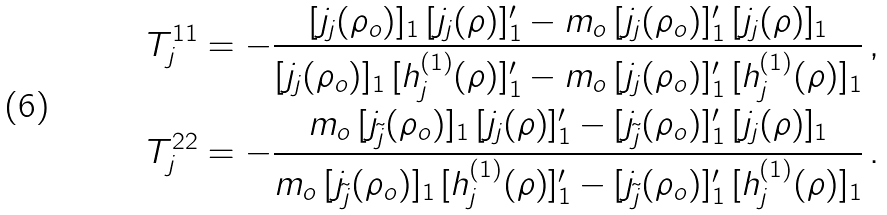<formula> <loc_0><loc_0><loc_500><loc_500>& T _ { j } ^ { 1 1 } = - \frac { [ j _ { j } ( \rho _ { o } ) ] _ { 1 } \, [ j _ { j } ( \rho ) ] ^ { \prime } _ { 1 } - m _ { o } \, [ j _ { j } ( \rho _ { o } ) ] ^ { \prime } _ { 1 } \, [ j _ { j } ( \rho ) ] _ { 1 } } { [ j _ { j } ( \rho _ { o } ) ] _ { 1 } \, [ h _ { j } ^ { ( 1 ) } ( \rho ) ] ^ { \prime } _ { 1 } - m _ { o } \, [ j _ { j } ( \rho _ { o } ) ] ^ { \prime } _ { 1 } \, [ h _ { j } ^ { ( 1 ) } ( \rho ) ] _ { 1 } } \, , \\ & T _ { j } ^ { 2 2 } = - \frac { m _ { o } \, [ j _ { \tilde { j } } ( \rho _ { o } ) ] _ { 1 } \, [ j _ { j } ( \rho ) ] ^ { \prime } _ { 1 } - [ j _ { \tilde { j } } ( \rho _ { o } ) ] ^ { \prime } _ { 1 } \, [ j _ { j } ( \rho ) ] _ { 1 } } { m _ { o } \, [ j _ { \tilde { j } } ( \rho _ { o } ) ] _ { 1 } \, [ h _ { j } ^ { ( 1 ) } ( \rho ) ] ^ { \prime } _ { 1 } - [ j _ { \tilde { j } } ( \rho _ { o } ) ] ^ { \prime } _ { 1 } \, [ h _ { j } ^ { ( 1 ) } ( \rho ) ] _ { 1 } } \, .</formula> 